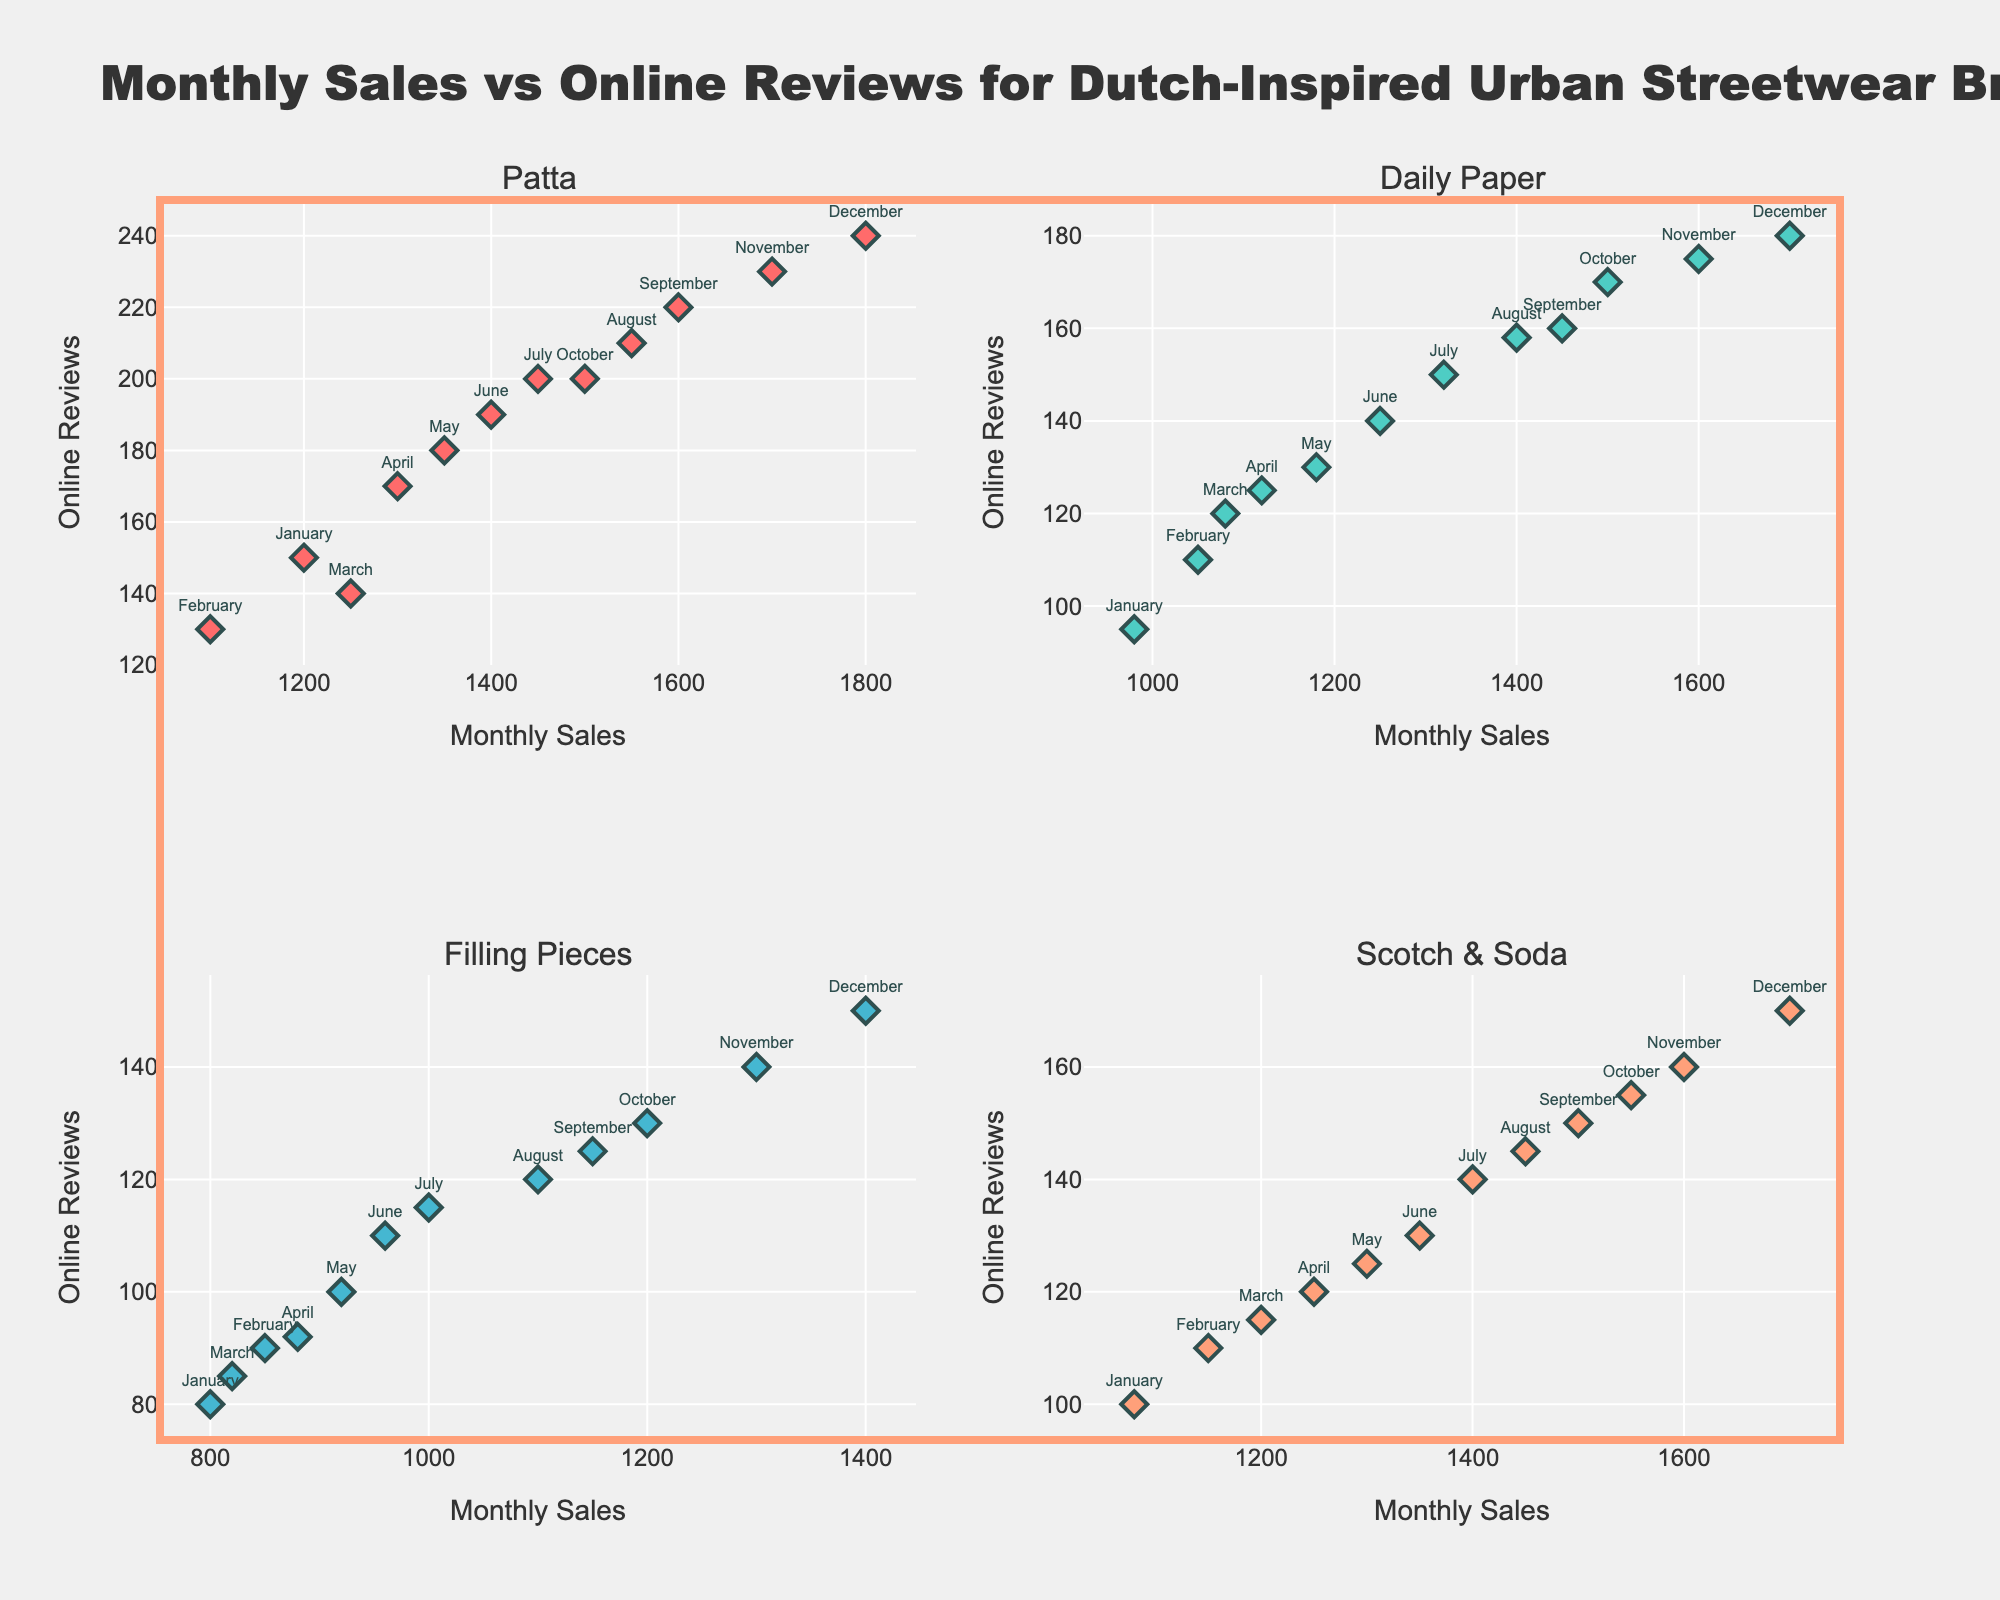What's the title of the figure? The title of the figure is positioned at the top-center and in a larger font size. The updated layout of the plot displays the title clearly.
Answer: Monthly Sales vs Online Reviews for Dutch-Inspired Urban Streetwear Brands How many data points are there for the brand "Patta"? By observing one of the scatter plots, count the number of markers that represent monthly data points for Patta. Each marker corresponds to one month of data.
Answer: 12 Which brand has the highest online reviews in December? Look at the scatter plots and check the markers labeled "December." Compare the y-values (Online Reviews) for that specific month across the brands.
Answer: Patta For the brand "Daily Paper," which month had the highest monthly sales? Locate the scatter plot for Daily Paper and identify the data point with the highest x-value (Monthly Sales). Check the label of that marker.
Answer: December What is the overall trend observed for "Filling Pieces"? Observe the scatter plot for Filling Pieces and note the overall direction of the markers. Both Monthly Sales and Online Reviews should be considered to determine the trend.
Answer: Increasing How do the monthly sales of Patta in November compare to those in September? Identify the markers labeled "November" and "September" on Patta's scatter plot. Compare their positions on the x-axis (Monthly Sales).
Answer: Higher in November If Scotch & Soda had 1600 online reviews, what would be their monthly sales? Locate the data point on Scotch & Soda’s scatter plot with y-value 1600 (Online Reviews) and observe its corresponding x-value (Monthly Sales).
Answer: 1600 Which brand shows the most dramatic increase in online reviews from January to December? Compare the difference in online reviews from January to December across all brands by looking at the y-values for those specific months.
Answer: Patta Which brand has the most consistent trend in monthly sales throughout the year? Look at the scatter plot for each brand and assess the variability of x-values (Monthly Sales). The most consistent trend will have the least fluctuations.
Answer: Daily Paper By looking at the trend of online reviews for "Scotch & Soda," in which month did a significant increase occur? Observe the scatter plot for Scotch & Soda and note any sharp increases in y-values (Online Reviews). Check the label of the corresponding month.
Answer: July 